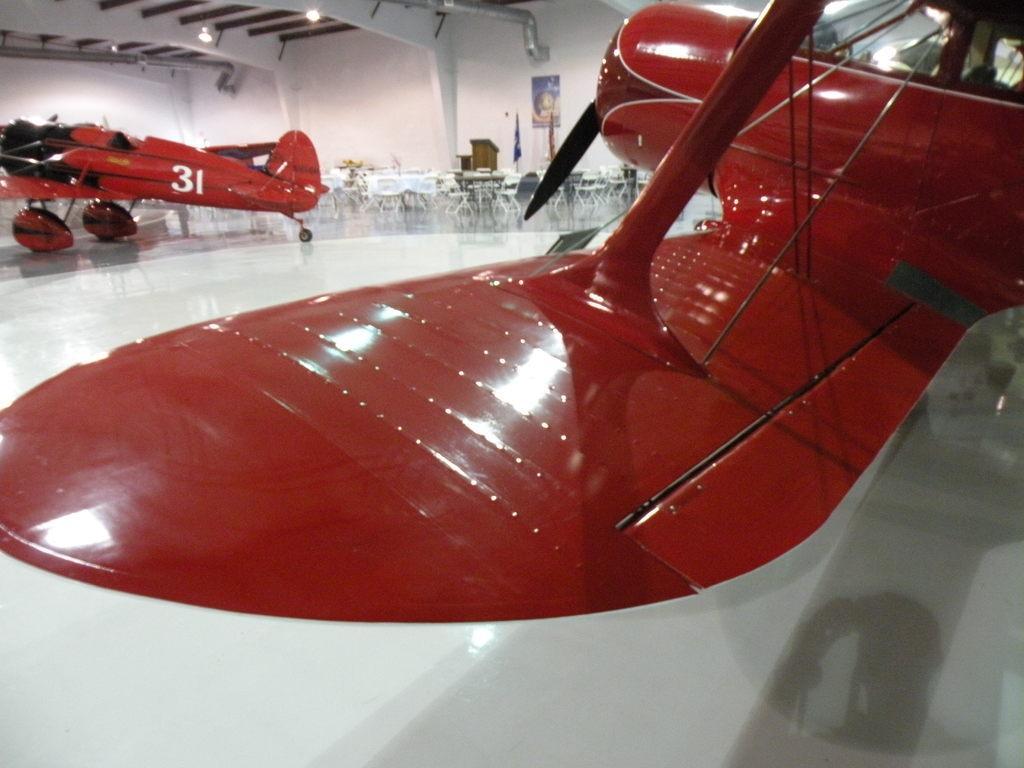Can you describe this image briefly? In this image, we can see aircrafts and in the background, there are chairs, table, flags and some stands and there is a poster on the wall. At the top, there are lights, rods and there is roof. At the bottom, there is floor. 